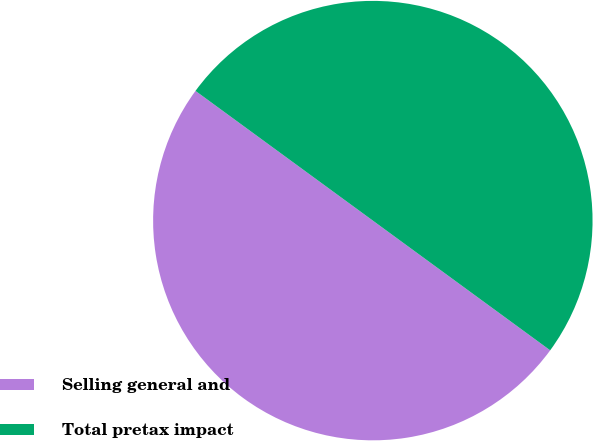<chart> <loc_0><loc_0><loc_500><loc_500><pie_chart><fcel>Selling general and<fcel>Total pretax impact<nl><fcel>50.0%<fcel>50.0%<nl></chart> 